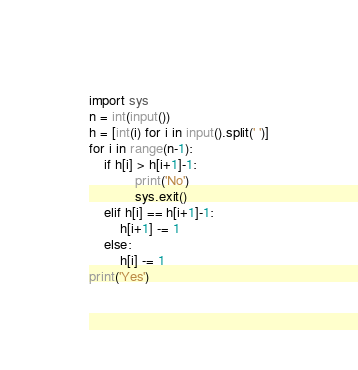Convert code to text. <code><loc_0><loc_0><loc_500><loc_500><_Python_>import sys
n = int(input())
h = [int(i) for i in input().split(' ')]
for i in range(n-1):
    if h[i] > h[i+1]-1:
            print('No')
            sys.exit()
    elif h[i] == h[i+1]-1:
        h[i+1] -= 1
    else:
        h[i] -= 1
print('Yes')</code> 